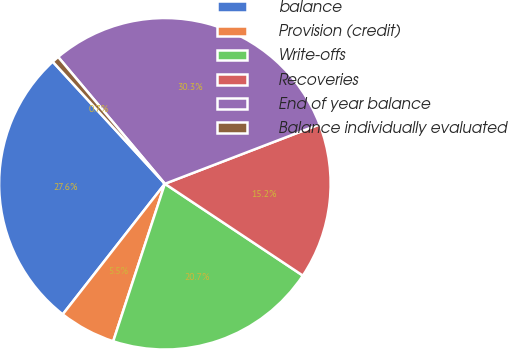<chart> <loc_0><loc_0><loc_500><loc_500><pie_chart><fcel>balance<fcel>Provision (credit)<fcel>Write-offs<fcel>Recoveries<fcel>End of year balance<fcel>Balance individually evaluated<nl><fcel>27.61%<fcel>5.52%<fcel>20.7%<fcel>15.18%<fcel>30.3%<fcel>0.69%<nl></chart> 